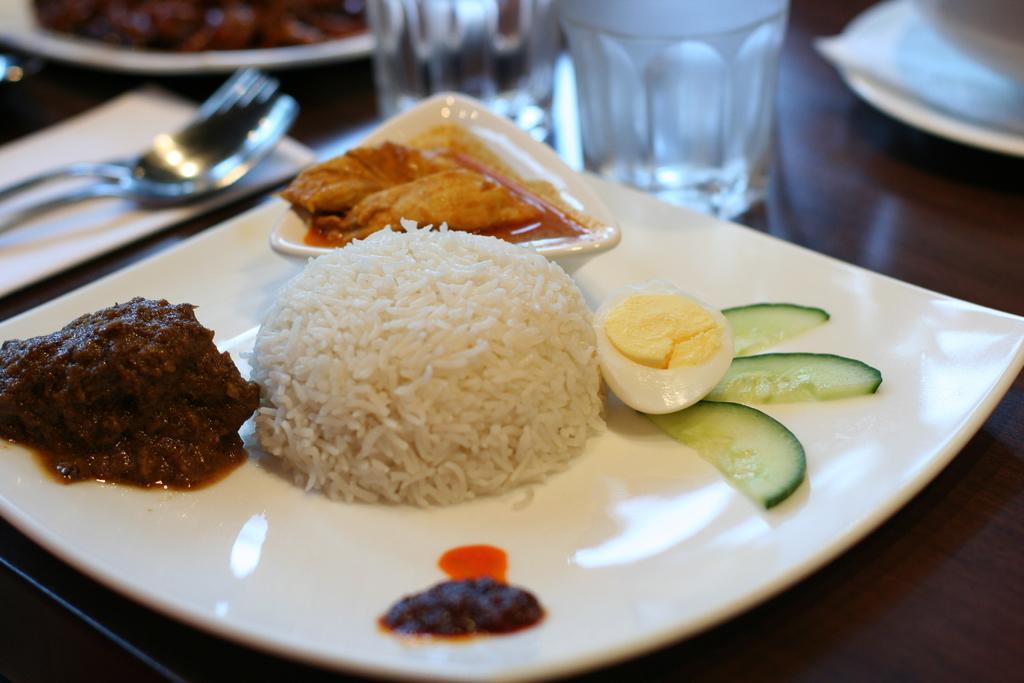Describe this image in one or two sentences. There is a plate in the foreground, on which there are food items and there are glass, plates, spoons and tissue on the table. 